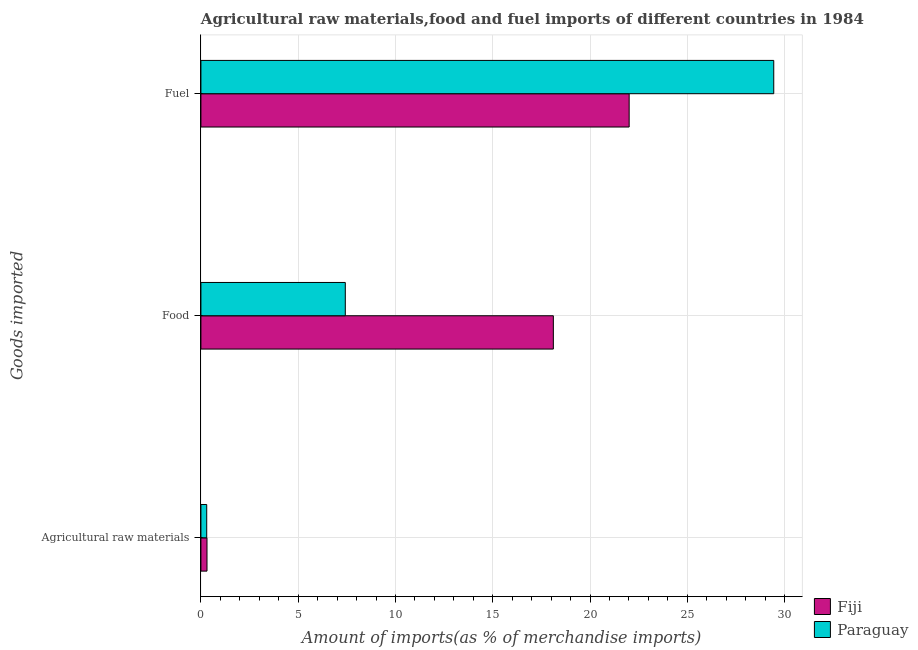Are the number of bars per tick equal to the number of legend labels?
Make the answer very short. Yes. Are the number of bars on each tick of the Y-axis equal?
Provide a succinct answer. Yes. What is the label of the 3rd group of bars from the top?
Provide a short and direct response. Agricultural raw materials. What is the percentage of raw materials imports in Paraguay?
Offer a very short reply. 0.3. Across all countries, what is the maximum percentage of raw materials imports?
Your answer should be compact. 0.31. Across all countries, what is the minimum percentage of raw materials imports?
Keep it short and to the point. 0.3. In which country was the percentage of fuel imports maximum?
Your answer should be very brief. Paraguay. In which country was the percentage of fuel imports minimum?
Provide a succinct answer. Fiji. What is the total percentage of raw materials imports in the graph?
Your answer should be compact. 0.61. What is the difference between the percentage of fuel imports in Fiji and that in Paraguay?
Provide a short and direct response. -7.43. What is the difference between the percentage of fuel imports in Fiji and the percentage of raw materials imports in Paraguay?
Offer a very short reply. 21.71. What is the average percentage of fuel imports per country?
Make the answer very short. 25.73. What is the difference between the percentage of raw materials imports and percentage of food imports in Fiji?
Offer a very short reply. -17.8. In how many countries, is the percentage of fuel imports greater than 1 %?
Provide a succinct answer. 2. What is the ratio of the percentage of fuel imports in Fiji to that in Paraguay?
Your answer should be very brief. 0.75. Is the percentage of fuel imports in Paraguay less than that in Fiji?
Keep it short and to the point. No. What is the difference between the highest and the second highest percentage of food imports?
Keep it short and to the point. 10.69. What is the difference between the highest and the lowest percentage of fuel imports?
Provide a short and direct response. 7.43. In how many countries, is the percentage of food imports greater than the average percentage of food imports taken over all countries?
Ensure brevity in your answer.  1. What does the 1st bar from the top in Agricultural raw materials represents?
Make the answer very short. Paraguay. What does the 1st bar from the bottom in Agricultural raw materials represents?
Give a very brief answer. Fiji. Is it the case that in every country, the sum of the percentage of raw materials imports and percentage of food imports is greater than the percentage of fuel imports?
Your answer should be compact. No. How many bars are there?
Make the answer very short. 6. Does the graph contain grids?
Offer a very short reply. Yes. Where does the legend appear in the graph?
Keep it short and to the point. Bottom right. What is the title of the graph?
Your response must be concise. Agricultural raw materials,food and fuel imports of different countries in 1984. Does "Comoros" appear as one of the legend labels in the graph?
Your response must be concise. No. What is the label or title of the X-axis?
Make the answer very short. Amount of imports(as % of merchandise imports). What is the label or title of the Y-axis?
Your response must be concise. Goods imported. What is the Amount of imports(as % of merchandise imports) in Fiji in Agricultural raw materials?
Provide a succinct answer. 0.31. What is the Amount of imports(as % of merchandise imports) of Paraguay in Agricultural raw materials?
Offer a terse response. 0.3. What is the Amount of imports(as % of merchandise imports) of Fiji in Food?
Offer a very short reply. 18.12. What is the Amount of imports(as % of merchandise imports) of Paraguay in Food?
Make the answer very short. 7.42. What is the Amount of imports(as % of merchandise imports) in Fiji in Fuel?
Ensure brevity in your answer.  22.01. What is the Amount of imports(as % of merchandise imports) of Paraguay in Fuel?
Offer a terse response. 29.44. Across all Goods imported, what is the maximum Amount of imports(as % of merchandise imports) in Fiji?
Provide a succinct answer. 22.01. Across all Goods imported, what is the maximum Amount of imports(as % of merchandise imports) in Paraguay?
Offer a terse response. 29.44. Across all Goods imported, what is the minimum Amount of imports(as % of merchandise imports) in Fiji?
Keep it short and to the point. 0.31. Across all Goods imported, what is the minimum Amount of imports(as % of merchandise imports) in Paraguay?
Give a very brief answer. 0.3. What is the total Amount of imports(as % of merchandise imports) in Fiji in the graph?
Keep it short and to the point. 40.44. What is the total Amount of imports(as % of merchandise imports) of Paraguay in the graph?
Offer a very short reply. 37.16. What is the difference between the Amount of imports(as % of merchandise imports) in Fiji in Agricultural raw materials and that in Food?
Provide a short and direct response. -17.8. What is the difference between the Amount of imports(as % of merchandise imports) in Paraguay in Agricultural raw materials and that in Food?
Keep it short and to the point. -7.12. What is the difference between the Amount of imports(as % of merchandise imports) in Fiji in Agricultural raw materials and that in Fuel?
Keep it short and to the point. -21.7. What is the difference between the Amount of imports(as % of merchandise imports) in Paraguay in Agricultural raw materials and that in Fuel?
Offer a very short reply. -29.15. What is the difference between the Amount of imports(as % of merchandise imports) in Fiji in Food and that in Fuel?
Your response must be concise. -3.9. What is the difference between the Amount of imports(as % of merchandise imports) in Paraguay in Food and that in Fuel?
Provide a short and direct response. -22.02. What is the difference between the Amount of imports(as % of merchandise imports) of Fiji in Agricultural raw materials and the Amount of imports(as % of merchandise imports) of Paraguay in Food?
Offer a terse response. -7.11. What is the difference between the Amount of imports(as % of merchandise imports) of Fiji in Agricultural raw materials and the Amount of imports(as % of merchandise imports) of Paraguay in Fuel?
Keep it short and to the point. -29.13. What is the difference between the Amount of imports(as % of merchandise imports) in Fiji in Food and the Amount of imports(as % of merchandise imports) in Paraguay in Fuel?
Offer a terse response. -11.33. What is the average Amount of imports(as % of merchandise imports) of Fiji per Goods imported?
Provide a short and direct response. 13.48. What is the average Amount of imports(as % of merchandise imports) of Paraguay per Goods imported?
Offer a terse response. 12.39. What is the difference between the Amount of imports(as % of merchandise imports) in Fiji and Amount of imports(as % of merchandise imports) in Paraguay in Agricultural raw materials?
Make the answer very short. 0.01. What is the difference between the Amount of imports(as % of merchandise imports) of Fiji and Amount of imports(as % of merchandise imports) of Paraguay in Food?
Your answer should be compact. 10.69. What is the difference between the Amount of imports(as % of merchandise imports) in Fiji and Amount of imports(as % of merchandise imports) in Paraguay in Fuel?
Offer a terse response. -7.43. What is the ratio of the Amount of imports(as % of merchandise imports) in Fiji in Agricultural raw materials to that in Food?
Your answer should be very brief. 0.02. What is the ratio of the Amount of imports(as % of merchandise imports) in Paraguay in Agricultural raw materials to that in Food?
Provide a succinct answer. 0.04. What is the ratio of the Amount of imports(as % of merchandise imports) of Fiji in Agricultural raw materials to that in Fuel?
Give a very brief answer. 0.01. What is the ratio of the Amount of imports(as % of merchandise imports) of Paraguay in Agricultural raw materials to that in Fuel?
Provide a succinct answer. 0.01. What is the ratio of the Amount of imports(as % of merchandise imports) in Fiji in Food to that in Fuel?
Give a very brief answer. 0.82. What is the ratio of the Amount of imports(as % of merchandise imports) in Paraguay in Food to that in Fuel?
Offer a very short reply. 0.25. What is the difference between the highest and the second highest Amount of imports(as % of merchandise imports) in Fiji?
Offer a terse response. 3.9. What is the difference between the highest and the second highest Amount of imports(as % of merchandise imports) of Paraguay?
Your answer should be compact. 22.02. What is the difference between the highest and the lowest Amount of imports(as % of merchandise imports) of Fiji?
Ensure brevity in your answer.  21.7. What is the difference between the highest and the lowest Amount of imports(as % of merchandise imports) in Paraguay?
Offer a terse response. 29.15. 